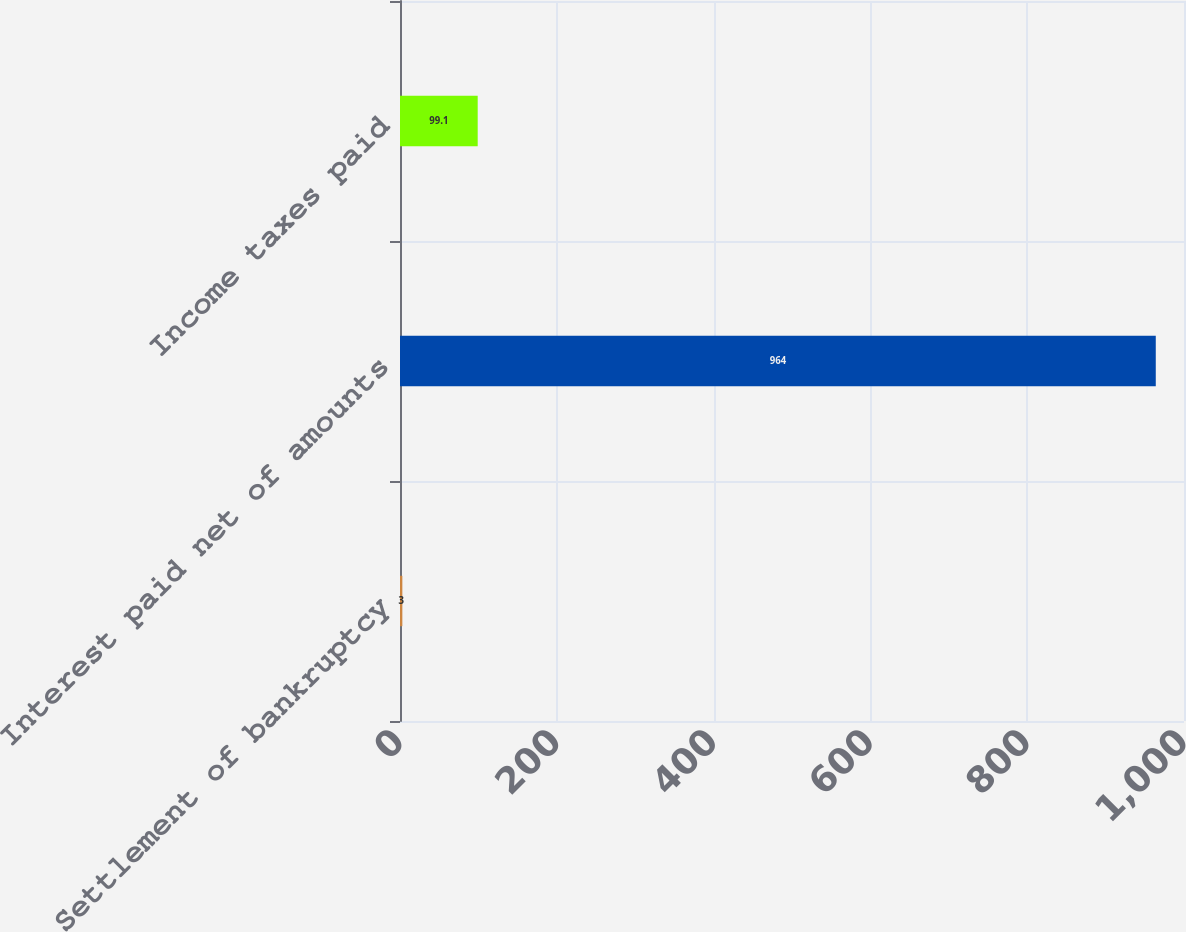Convert chart to OTSL. <chart><loc_0><loc_0><loc_500><loc_500><bar_chart><fcel>Settlement of bankruptcy<fcel>Interest paid net of amounts<fcel>Income taxes paid<nl><fcel>3<fcel>964<fcel>99.1<nl></chart> 